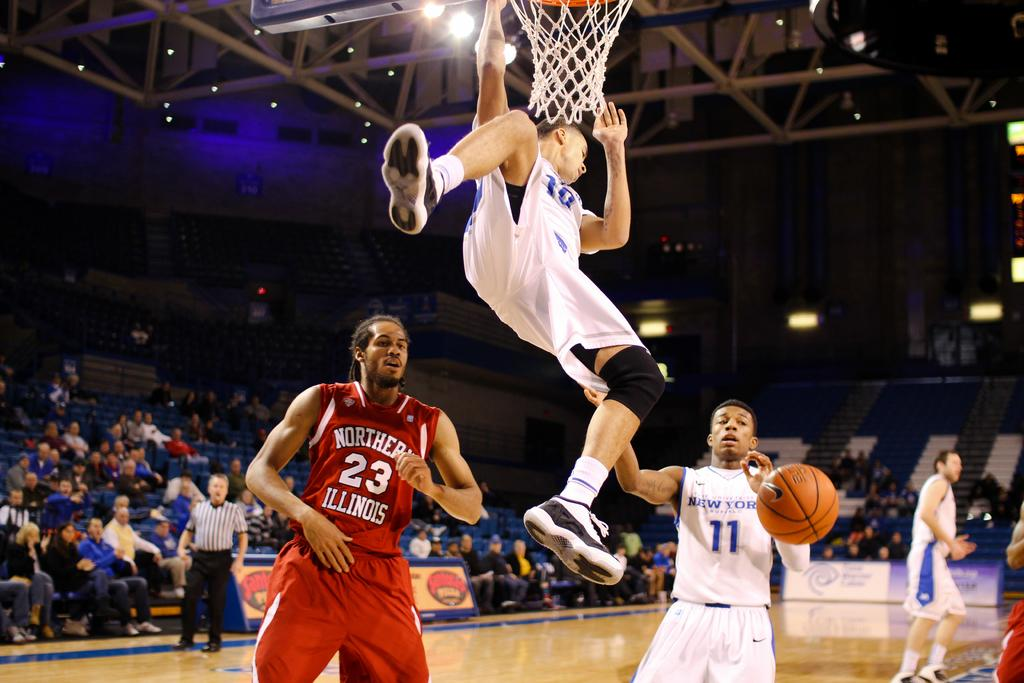<image>
Summarize the visual content of the image. a person playing basketball with the number 11 